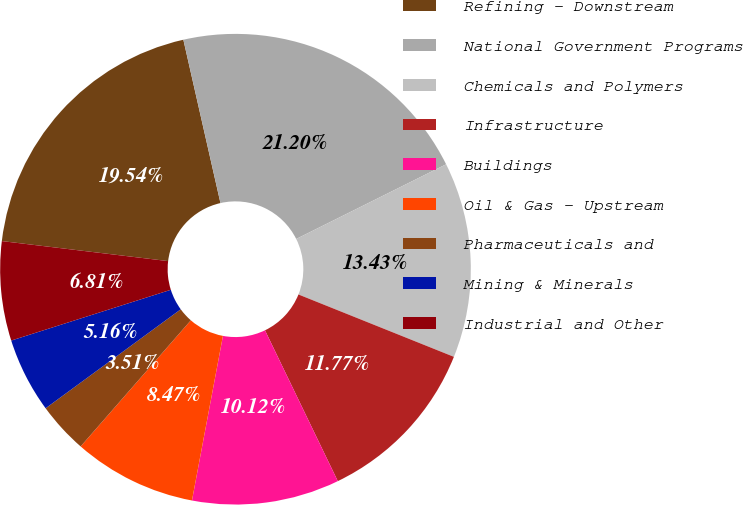Convert chart. <chart><loc_0><loc_0><loc_500><loc_500><pie_chart><fcel>Refining - Downstream<fcel>National Government Programs<fcel>Chemicals and Polymers<fcel>Infrastructure<fcel>Buildings<fcel>Oil & Gas - Upstream<fcel>Pharmaceuticals and<fcel>Mining & Minerals<fcel>Industrial and Other<nl><fcel>19.54%<fcel>21.2%<fcel>13.43%<fcel>11.77%<fcel>10.12%<fcel>8.47%<fcel>3.51%<fcel>5.16%<fcel>6.81%<nl></chart> 